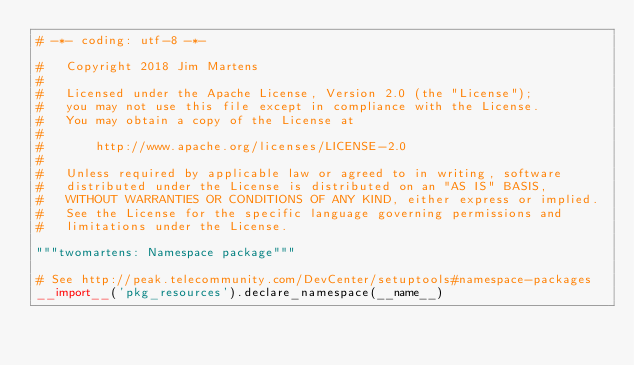Convert code to text. <code><loc_0><loc_0><loc_500><loc_500><_Python_># -*- coding: utf-8 -*-

#   Copyright 2018 Jim Martens
#
#   Licensed under the Apache License, Version 2.0 (the "License");
#   you may not use this file except in compliance with the License.
#   You may obtain a copy of the License at
#
#       http://www.apache.org/licenses/LICENSE-2.0
#
#   Unless required by applicable law or agreed to in writing, software
#   distributed under the License is distributed on an "AS IS" BASIS,
#   WITHOUT WARRANTIES OR CONDITIONS OF ANY KIND, either express or implied.
#   See the License for the specific language governing permissions and
#   limitations under the License.

"""twomartens: Namespace package"""

# See http://peak.telecommunity.com/DevCenter/setuptools#namespace-packages
__import__('pkg_resources').declare_namespace(__name__)
</code> 